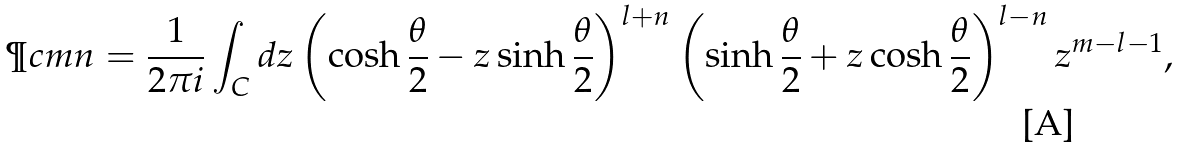<formula> <loc_0><loc_0><loc_500><loc_500>\P c m n = \frac { 1 } { 2 \pi i } \int _ { C } d z \left ( \cosh \frac { \theta } { 2 } - z \sinh \frac { \theta } { 2 } \right ) ^ { l + n } \left ( \sinh \frac { \theta } { 2 } + z \cosh \frac { \theta } { 2 } \right ) ^ { l - n } z ^ { m - l - 1 } ,</formula> 